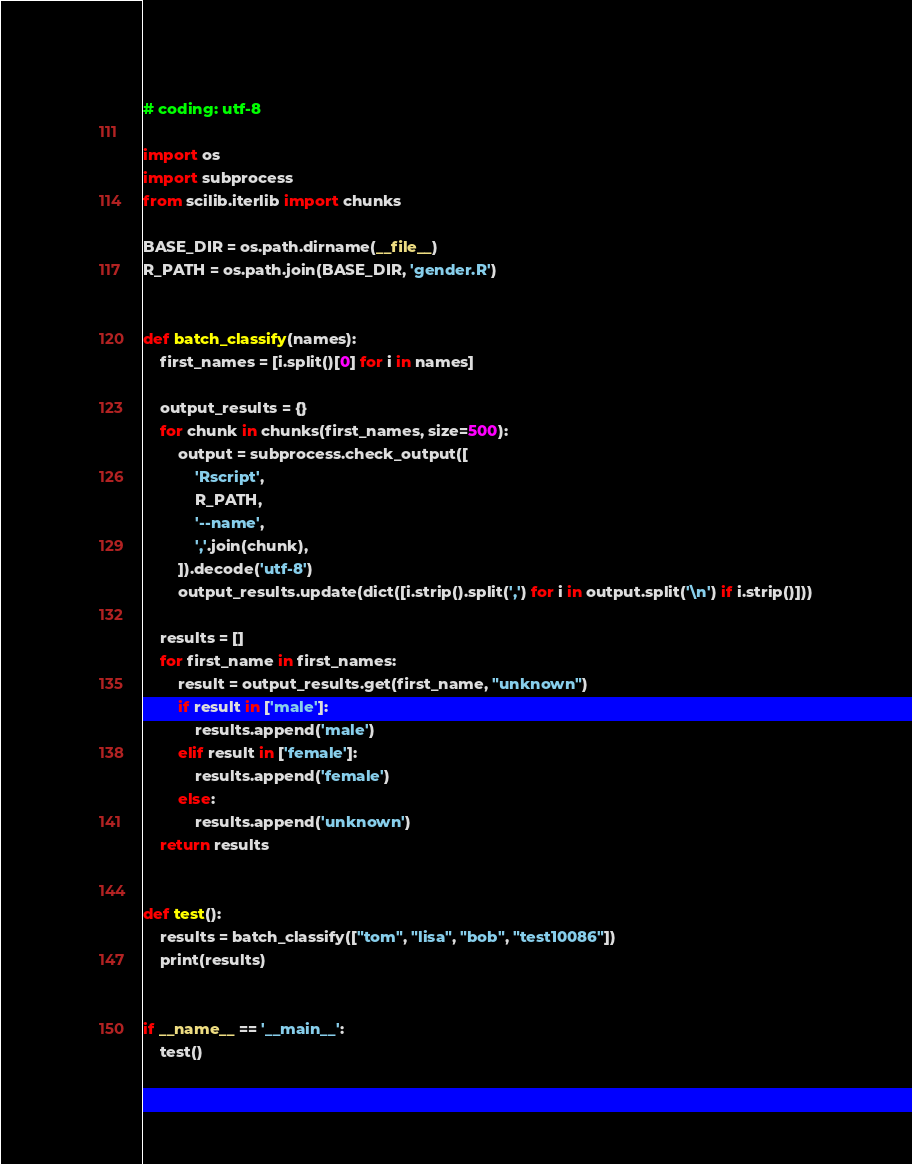Convert code to text. <code><loc_0><loc_0><loc_500><loc_500><_Python_># coding: utf-8

import os
import subprocess
from scilib.iterlib import chunks

BASE_DIR = os.path.dirname(__file__)
R_PATH = os.path.join(BASE_DIR, 'gender.R')


def batch_classify(names):
    first_names = [i.split()[0] for i in names]

    output_results = {}
    for chunk in chunks(first_names, size=500):
        output = subprocess.check_output([
            'Rscript',
            R_PATH,
            '--name',
            ','.join(chunk),
        ]).decode('utf-8')
        output_results.update(dict([i.strip().split(',') for i in output.split('\n') if i.strip()]))

    results = []
    for first_name in first_names:
        result = output_results.get(first_name, "unknown")
        if result in ['male']:
            results.append('male')
        elif result in ['female']:
            results.append('female')
        else:
            results.append('unknown')
    return results


def test():
    results = batch_classify(["tom", "lisa", "bob", "test10086"])
    print(results)


if __name__ == '__main__':
    test()
</code> 